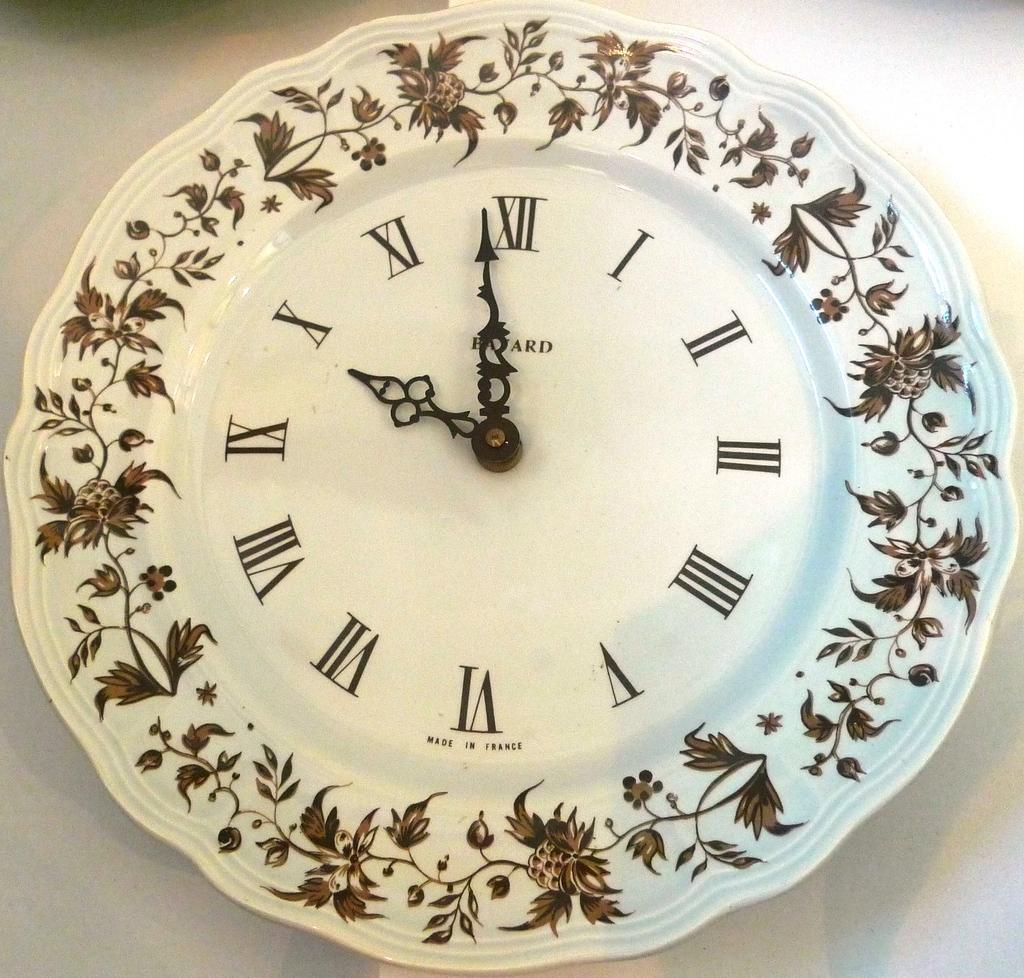<image>
Summarize the visual content of the image. A clock that is displaying the time of 9:58 